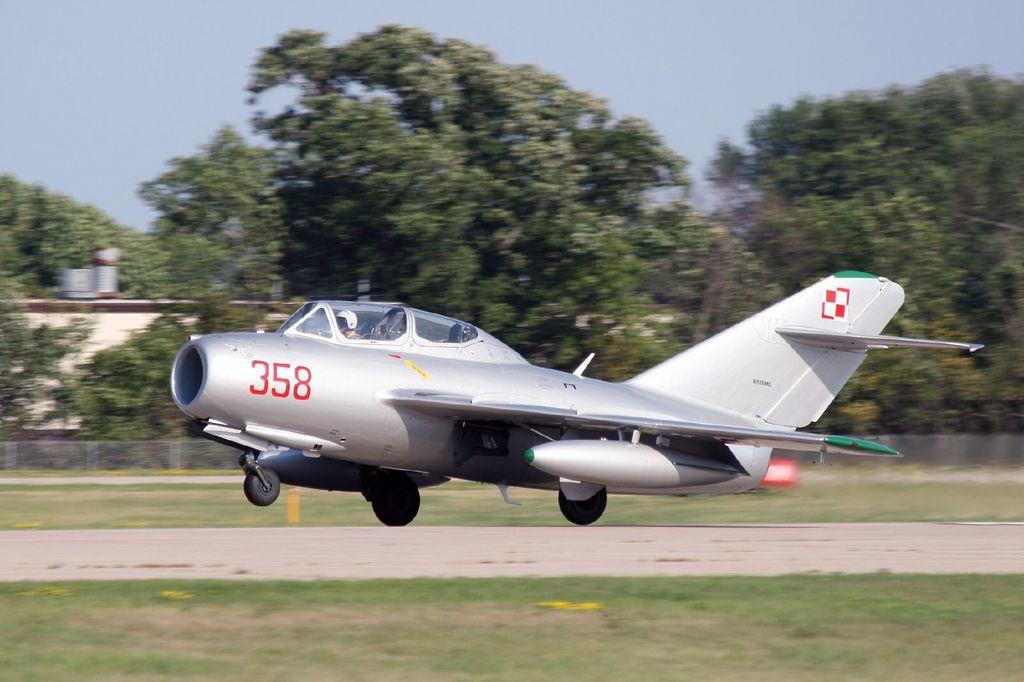Can you describe this image briefly? In the center of the image we can see persons in aeroplane. At the bottom of the image we can see runway and grass. In the background we can see trees, building, grass and sky. 